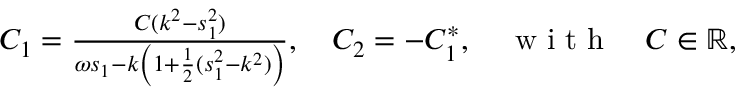<formula> <loc_0><loc_0><loc_500><loc_500>\begin{array} { r } { C _ { 1 } = \frac { C ( k ^ { 2 } - s _ { 1 } ^ { 2 } ) } { \omega s _ { 1 } - k \left ( 1 + \frac { 1 } { 2 } ( s _ { 1 } ^ { 2 } - k ^ { 2 } ) \right ) } , \quad C _ { 2 } = - C _ { 1 } ^ { * } , \quad w i t h \quad C \in \mathbb { R } , } \end{array}</formula> 